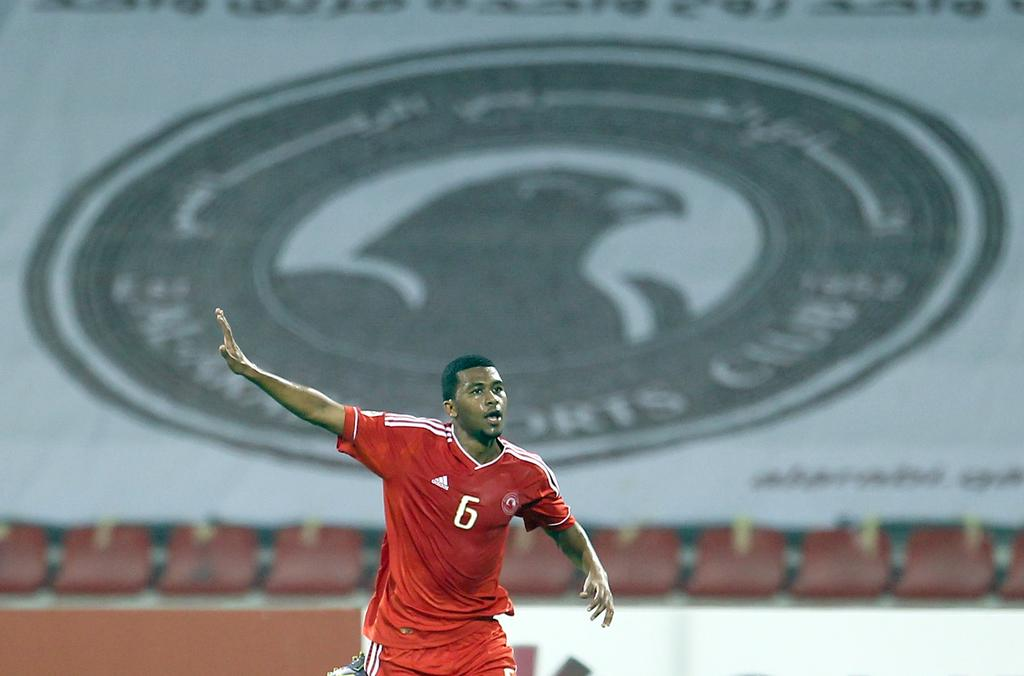<image>
Offer a succinct explanation of the picture presented. An athlete dressed in all red gesturing in front of a giant sports club logo with a bird on it. 